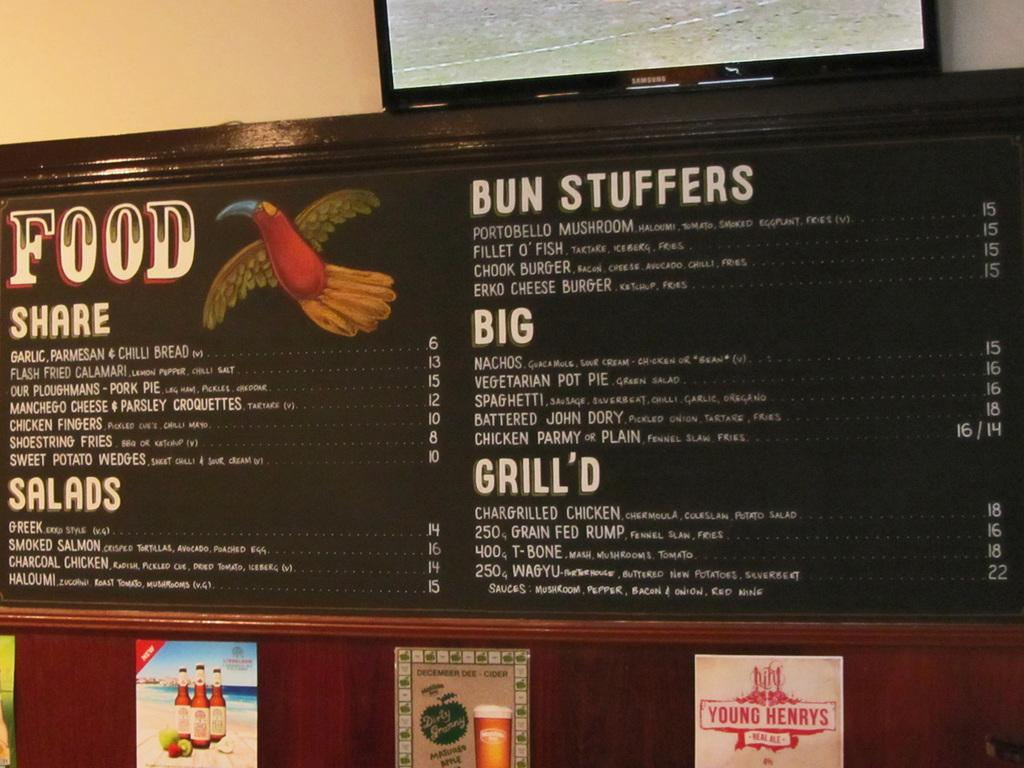Provide a one-sentence caption for the provided image. A restaurant menu on the wall which offers Bun Stuffers as an option. 